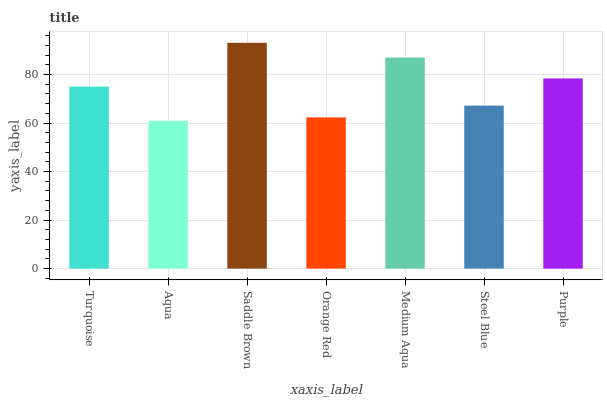Is Aqua the minimum?
Answer yes or no. Yes. Is Saddle Brown the maximum?
Answer yes or no. Yes. Is Saddle Brown the minimum?
Answer yes or no. No. Is Aqua the maximum?
Answer yes or no. No. Is Saddle Brown greater than Aqua?
Answer yes or no. Yes. Is Aqua less than Saddle Brown?
Answer yes or no. Yes. Is Aqua greater than Saddle Brown?
Answer yes or no. No. Is Saddle Brown less than Aqua?
Answer yes or no. No. Is Turquoise the high median?
Answer yes or no. Yes. Is Turquoise the low median?
Answer yes or no. Yes. Is Steel Blue the high median?
Answer yes or no. No. Is Medium Aqua the low median?
Answer yes or no. No. 